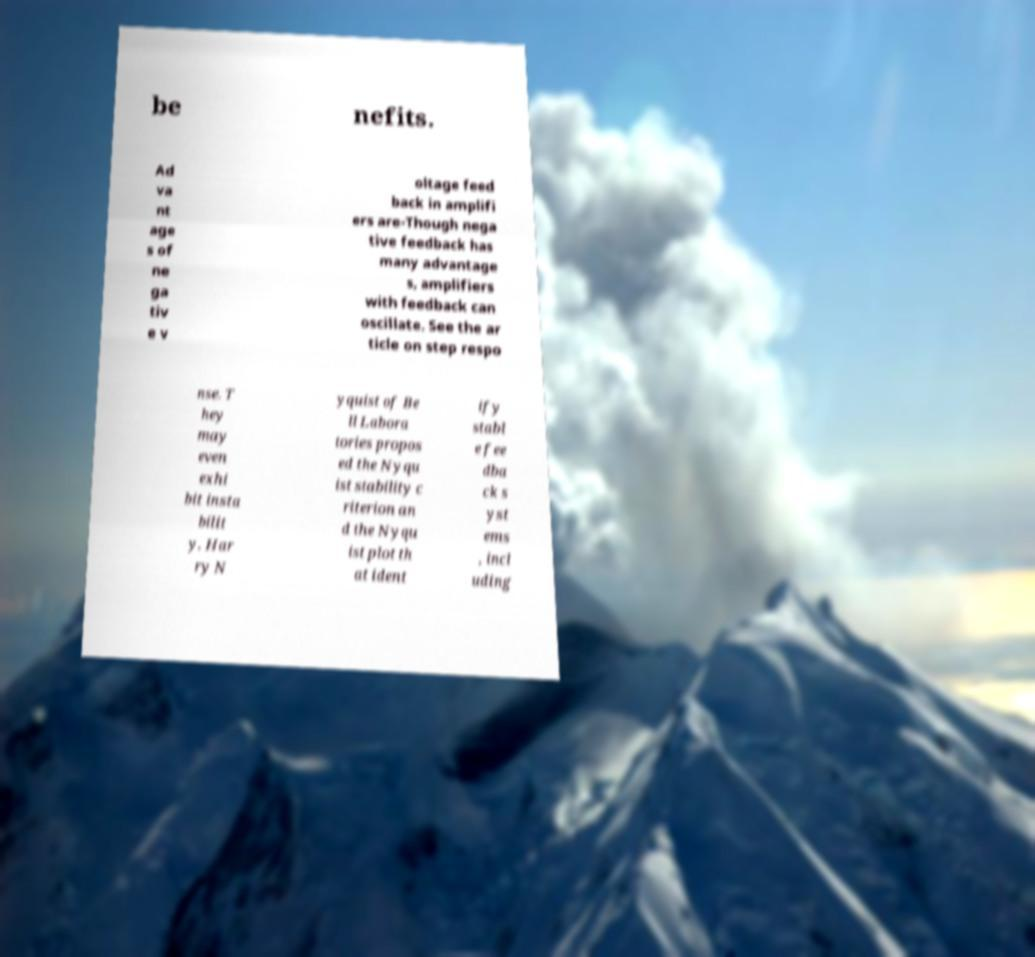What messages or text are displayed in this image? I need them in a readable, typed format. be nefits. Ad va nt age s of ne ga tiv e v oltage feed back in amplifi ers are-Though nega tive feedback has many advantage s, amplifiers with feedback can oscillate. See the ar ticle on step respo nse. T hey may even exhi bit insta bilit y. Har ry N yquist of Be ll Labora tories propos ed the Nyqu ist stability c riterion an d the Nyqu ist plot th at ident ify stabl e fee dba ck s yst ems , incl uding 